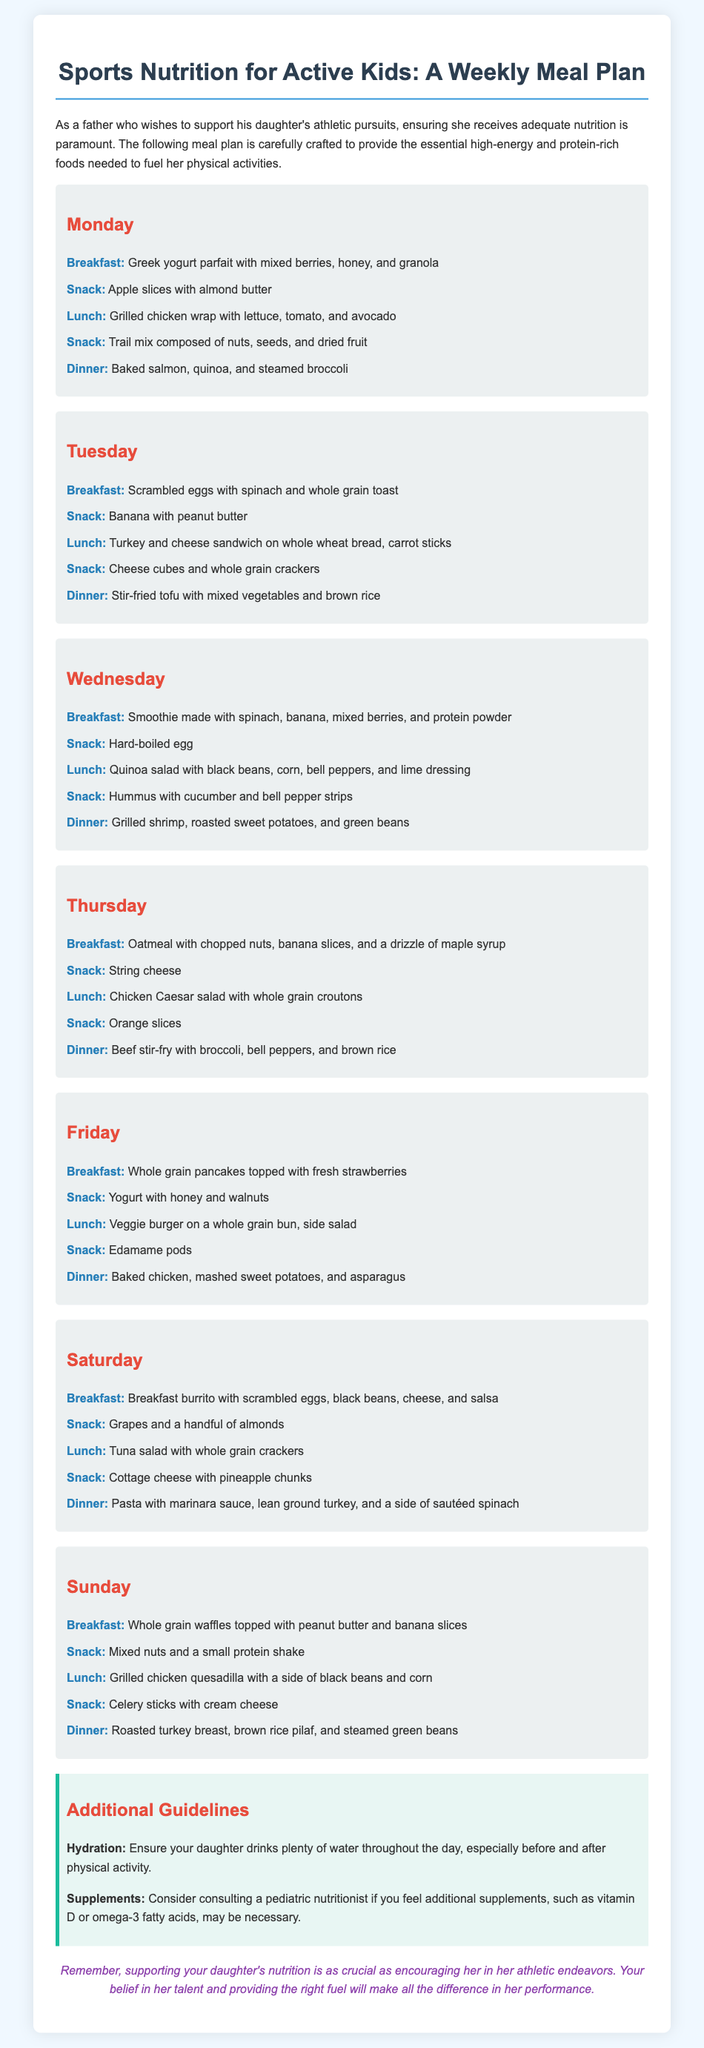What is the meal for breakfast on Monday? The breakfast meal on Monday is specified as Greek yogurt parfait with mixed berries, honey, and granola.
Answer: Greek yogurt parfait with mixed berries, honey, and granola How many snacks are listed for Tuesday? The document provides a total of four snacks listed under Tuesday, which include banana with peanut butter, cheese cubes and whole grain crackers, and more.
Answer: 4 What is the main protein source for dinner on Friday? The dinner on Friday features baked chicken, which serves as the main protein source for that meal.
Answer: Baked chicken Which day includes a smoothie for breakfast? The breakfast on Wednesday includes a smoothie made with spinach, banana, mixed berries, and protein powder.
Answer: Wednesday What vegetable is paired with the baked salmon dinner? The vegetable included with the baked salmon dinner is steamed broccoli.
Answer: Steamed broccoli Which of the meals contains string cheese as a snack? String cheese is listed as a snack on Thursday in the meal plan.
Answer: Thursday What is the hydration recommendation mentioned in the guidelines? The hydration recommendation emphasizes ensuring your daughter drinks plenty of water throughout the day, especially before and after physical activity.
Answer: Plenty of water Which day features a breakfast burrito? The breakfast burrito is specifically mentioned for Saturday as part of the meal plan.
Answer: Saturday What type of salad is served for lunch on Thursday? On Thursday, a chicken Caesar salad with whole grain croutons is specified for lunch.
Answer: Chicken Caesar salad 